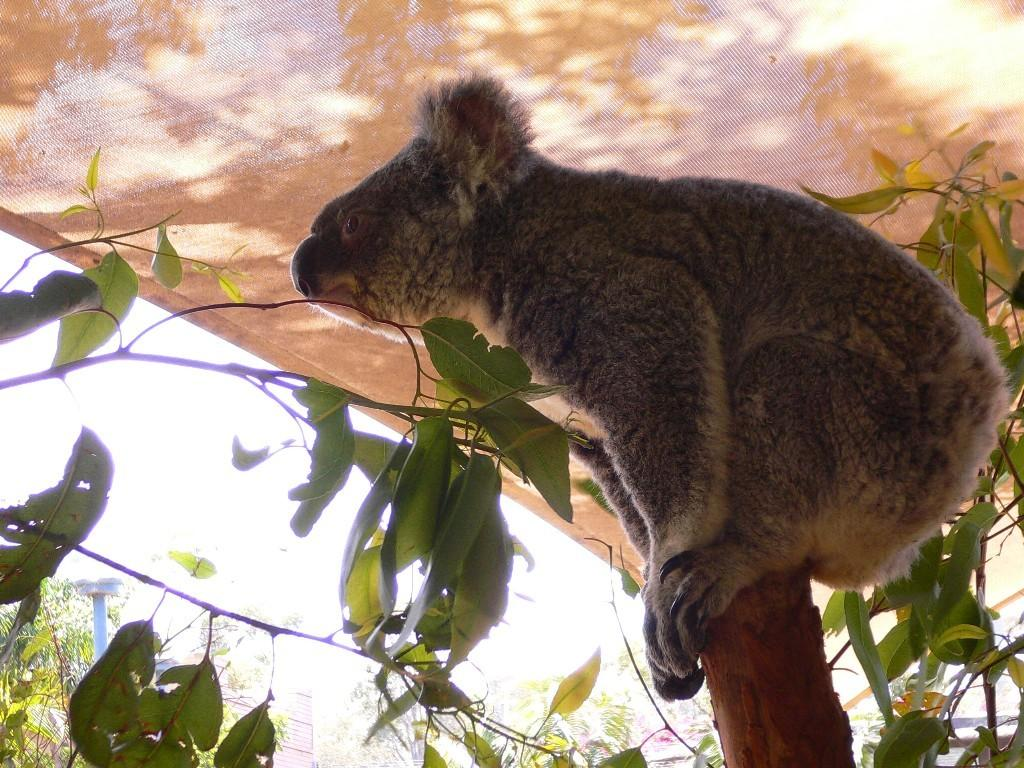What type of animal can be seen in the image? There is an animal in the image, but its specific type is not mentioned in the facts. Where is the animal located in the image? The animal is under a tent and sitting on a wooden pole. What can be seen in the background of the image? There are trees and buildings visible in the image. What type of leather is the animal wearing as a scarf in the image? There is no leather or scarf present in the image. The animal is sitting on a wooden pole and is not wearing any clothing or accessories. 